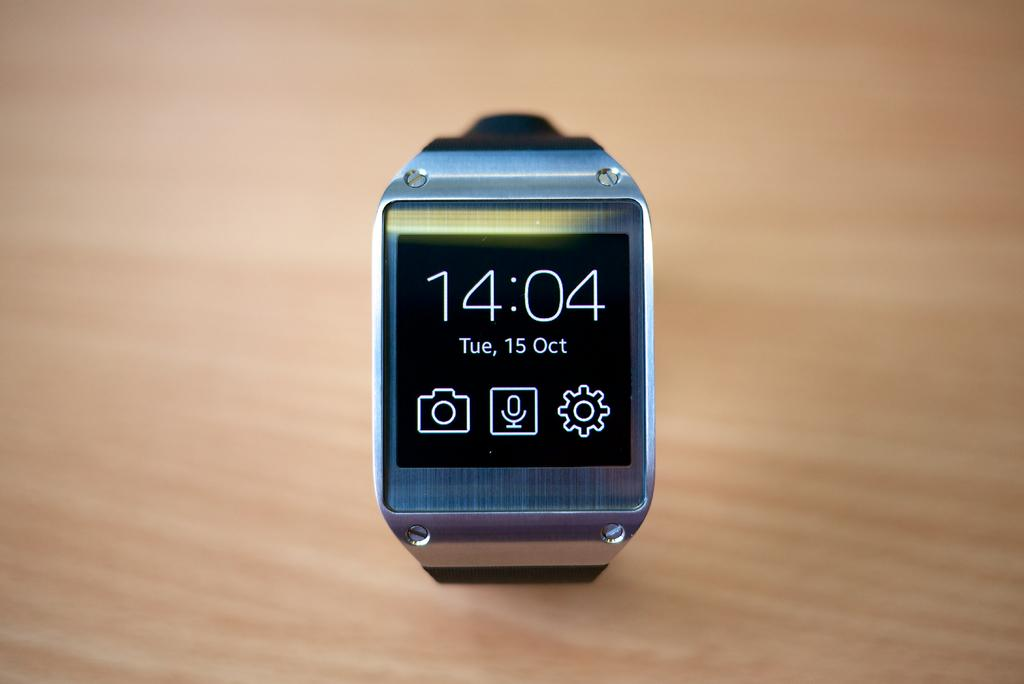<image>
Offer a succinct explanation of the picture presented. A digital watch shows the time of 14:04 and the day of Tue. 